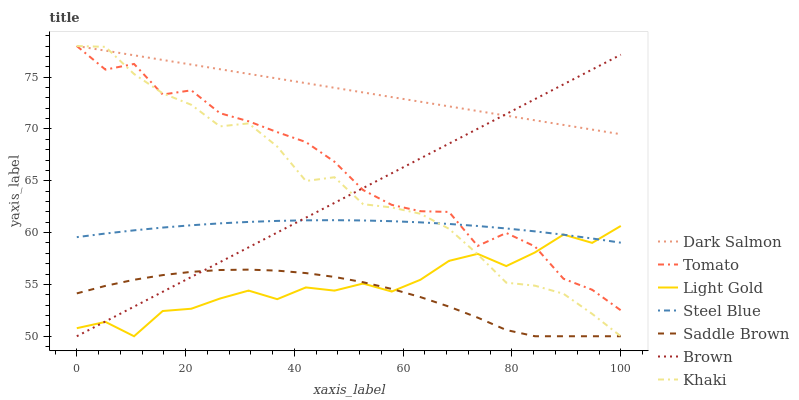Does Saddle Brown have the minimum area under the curve?
Answer yes or no. Yes. Does Dark Salmon have the maximum area under the curve?
Answer yes or no. Yes. Does Brown have the minimum area under the curve?
Answer yes or no. No. Does Brown have the maximum area under the curve?
Answer yes or no. No. Is Brown the smoothest?
Answer yes or no. Yes. Is Tomato the roughest?
Answer yes or no. Yes. Is Khaki the smoothest?
Answer yes or no. No. Is Khaki the roughest?
Answer yes or no. No. Does Brown have the lowest value?
Answer yes or no. Yes. Does Dark Salmon have the lowest value?
Answer yes or no. No. Does Dark Salmon have the highest value?
Answer yes or no. Yes. Does Brown have the highest value?
Answer yes or no. No. Is Saddle Brown less than Dark Salmon?
Answer yes or no. Yes. Is Dark Salmon greater than Steel Blue?
Answer yes or no. Yes. Does Khaki intersect Steel Blue?
Answer yes or no. Yes. Is Khaki less than Steel Blue?
Answer yes or no. No. Is Khaki greater than Steel Blue?
Answer yes or no. No. Does Saddle Brown intersect Dark Salmon?
Answer yes or no. No. 